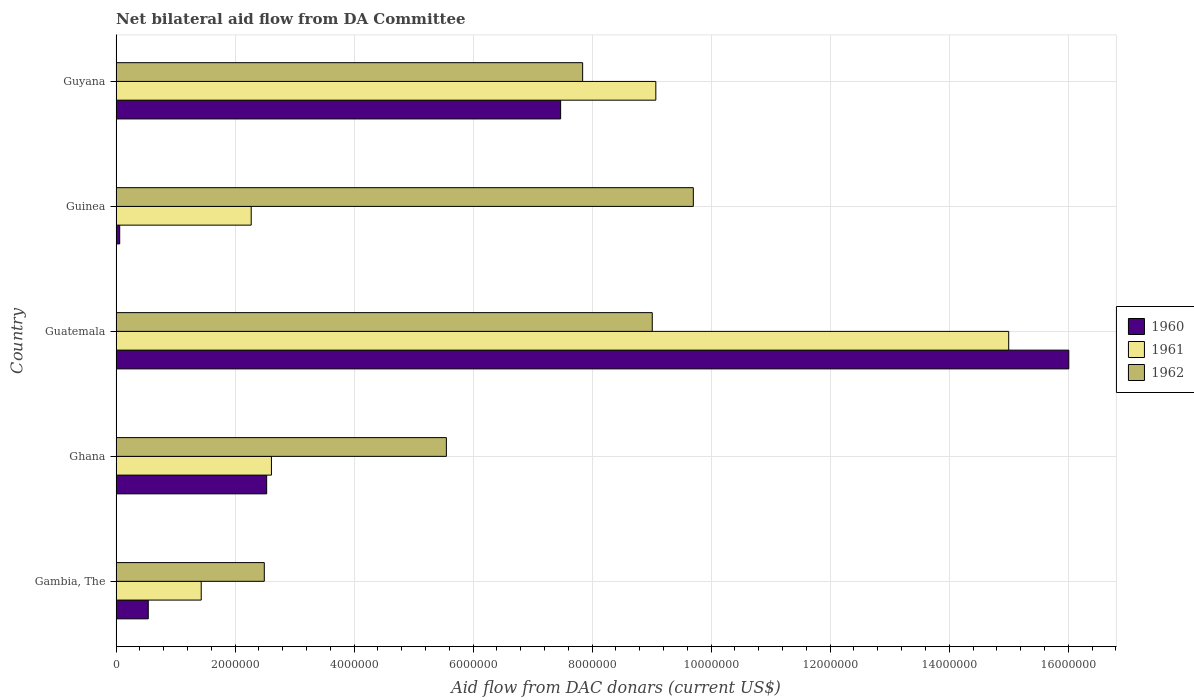How many groups of bars are there?
Give a very brief answer. 5. How many bars are there on the 4th tick from the top?
Keep it short and to the point. 3. How many bars are there on the 5th tick from the bottom?
Keep it short and to the point. 3. What is the label of the 4th group of bars from the top?
Your answer should be compact. Ghana. What is the aid flow in in 1962 in Guinea?
Make the answer very short. 9.70e+06. Across all countries, what is the maximum aid flow in in 1962?
Keep it short and to the point. 9.70e+06. Across all countries, what is the minimum aid flow in in 1962?
Offer a terse response. 2.49e+06. In which country was the aid flow in in 1961 maximum?
Your answer should be very brief. Guatemala. In which country was the aid flow in in 1961 minimum?
Your response must be concise. Gambia, The. What is the total aid flow in in 1962 in the graph?
Ensure brevity in your answer.  3.46e+07. What is the difference between the aid flow in in 1961 in Ghana and that in Guinea?
Offer a very short reply. 3.40e+05. What is the difference between the aid flow in in 1962 in Gambia, The and the aid flow in in 1961 in Guatemala?
Your answer should be compact. -1.25e+07. What is the average aid flow in in 1961 per country?
Offer a terse response. 6.08e+06. What is the difference between the aid flow in in 1961 and aid flow in in 1962 in Gambia, The?
Give a very brief answer. -1.06e+06. What is the ratio of the aid flow in in 1961 in Ghana to that in Guatemala?
Your answer should be very brief. 0.17. Is the aid flow in in 1962 in Gambia, The less than that in Guyana?
Offer a terse response. Yes. What is the difference between the highest and the second highest aid flow in in 1961?
Your answer should be very brief. 5.93e+06. What is the difference between the highest and the lowest aid flow in in 1960?
Provide a succinct answer. 1.60e+07. In how many countries, is the aid flow in in 1961 greater than the average aid flow in in 1961 taken over all countries?
Provide a short and direct response. 2. Is the sum of the aid flow in in 1960 in Ghana and Guyana greater than the maximum aid flow in in 1961 across all countries?
Provide a succinct answer. No. What does the 3rd bar from the top in Guinea represents?
Your answer should be very brief. 1960. How many bars are there?
Make the answer very short. 15. Are all the bars in the graph horizontal?
Offer a terse response. Yes. Are the values on the major ticks of X-axis written in scientific E-notation?
Offer a terse response. No. Does the graph contain any zero values?
Your response must be concise. No. Does the graph contain grids?
Ensure brevity in your answer.  Yes. Where does the legend appear in the graph?
Ensure brevity in your answer.  Center right. How many legend labels are there?
Offer a very short reply. 3. What is the title of the graph?
Offer a terse response. Net bilateral aid flow from DA Committee. What is the label or title of the X-axis?
Your answer should be very brief. Aid flow from DAC donars (current US$). What is the label or title of the Y-axis?
Ensure brevity in your answer.  Country. What is the Aid flow from DAC donars (current US$) in 1960 in Gambia, The?
Provide a short and direct response. 5.40e+05. What is the Aid flow from DAC donars (current US$) of 1961 in Gambia, The?
Ensure brevity in your answer.  1.43e+06. What is the Aid flow from DAC donars (current US$) of 1962 in Gambia, The?
Offer a terse response. 2.49e+06. What is the Aid flow from DAC donars (current US$) in 1960 in Ghana?
Your answer should be compact. 2.53e+06. What is the Aid flow from DAC donars (current US$) of 1961 in Ghana?
Offer a terse response. 2.61e+06. What is the Aid flow from DAC donars (current US$) in 1962 in Ghana?
Give a very brief answer. 5.55e+06. What is the Aid flow from DAC donars (current US$) of 1960 in Guatemala?
Give a very brief answer. 1.60e+07. What is the Aid flow from DAC donars (current US$) in 1961 in Guatemala?
Ensure brevity in your answer.  1.50e+07. What is the Aid flow from DAC donars (current US$) of 1962 in Guatemala?
Give a very brief answer. 9.01e+06. What is the Aid flow from DAC donars (current US$) in 1960 in Guinea?
Offer a terse response. 6.00e+04. What is the Aid flow from DAC donars (current US$) of 1961 in Guinea?
Your response must be concise. 2.27e+06. What is the Aid flow from DAC donars (current US$) of 1962 in Guinea?
Ensure brevity in your answer.  9.70e+06. What is the Aid flow from DAC donars (current US$) in 1960 in Guyana?
Ensure brevity in your answer.  7.47e+06. What is the Aid flow from DAC donars (current US$) of 1961 in Guyana?
Provide a succinct answer. 9.07e+06. What is the Aid flow from DAC donars (current US$) in 1962 in Guyana?
Offer a terse response. 7.84e+06. Across all countries, what is the maximum Aid flow from DAC donars (current US$) in 1960?
Keep it short and to the point. 1.60e+07. Across all countries, what is the maximum Aid flow from DAC donars (current US$) in 1961?
Offer a very short reply. 1.50e+07. Across all countries, what is the maximum Aid flow from DAC donars (current US$) in 1962?
Your answer should be compact. 9.70e+06. Across all countries, what is the minimum Aid flow from DAC donars (current US$) in 1960?
Offer a very short reply. 6.00e+04. Across all countries, what is the minimum Aid flow from DAC donars (current US$) in 1961?
Offer a very short reply. 1.43e+06. Across all countries, what is the minimum Aid flow from DAC donars (current US$) of 1962?
Your answer should be very brief. 2.49e+06. What is the total Aid flow from DAC donars (current US$) in 1960 in the graph?
Offer a very short reply. 2.66e+07. What is the total Aid flow from DAC donars (current US$) of 1961 in the graph?
Your answer should be very brief. 3.04e+07. What is the total Aid flow from DAC donars (current US$) in 1962 in the graph?
Provide a short and direct response. 3.46e+07. What is the difference between the Aid flow from DAC donars (current US$) of 1960 in Gambia, The and that in Ghana?
Provide a short and direct response. -1.99e+06. What is the difference between the Aid flow from DAC donars (current US$) of 1961 in Gambia, The and that in Ghana?
Your answer should be very brief. -1.18e+06. What is the difference between the Aid flow from DAC donars (current US$) of 1962 in Gambia, The and that in Ghana?
Give a very brief answer. -3.06e+06. What is the difference between the Aid flow from DAC donars (current US$) in 1960 in Gambia, The and that in Guatemala?
Ensure brevity in your answer.  -1.55e+07. What is the difference between the Aid flow from DAC donars (current US$) of 1961 in Gambia, The and that in Guatemala?
Ensure brevity in your answer.  -1.36e+07. What is the difference between the Aid flow from DAC donars (current US$) in 1962 in Gambia, The and that in Guatemala?
Your answer should be compact. -6.52e+06. What is the difference between the Aid flow from DAC donars (current US$) of 1960 in Gambia, The and that in Guinea?
Offer a terse response. 4.80e+05. What is the difference between the Aid flow from DAC donars (current US$) in 1961 in Gambia, The and that in Guinea?
Give a very brief answer. -8.40e+05. What is the difference between the Aid flow from DAC donars (current US$) of 1962 in Gambia, The and that in Guinea?
Provide a succinct answer. -7.21e+06. What is the difference between the Aid flow from DAC donars (current US$) in 1960 in Gambia, The and that in Guyana?
Give a very brief answer. -6.93e+06. What is the difference between the Aid flow from DAC donars (current US$) in 1961 in Gambia, The and that in Guyana?
Your answer should be compact. -7.64e+06. What is the difference between the Aid flow from DAC donars (current US$) in 1962 in Gambia, The and that in Guyana?
Offer a very short reply. -5.35e+06. What is the difference between the Aid flow from DAC donars (current US$) in 1960 in Ghana and that in Guatemala?
Provide a succinct answer. -1.35e+07. What is the difference between the Aid flow from DAC donars (current US$) in 1961 in Ghana and that in Guatemala?
Offer a very short reply. -1.24e+07. What is the difference between the Aid flow from DAC donars (current US$) in 1962 in Ghana and that in Guatemala?
Give a very brief answer. -3.46e+06. What is the difference between the Aid flow from DAC donars (current US$) in 1960 in Ghana and that in Guinea?
Ensure brevity in your answer.  2.47e+06. What is the difference between the Aid flow from DAC donars (current US$) of 1962 in Ghana and that in Guinea?
Your answer should be very brief. -4.15e+06. What is the difference between the Aid flow from DAC donars (current US$) of 1960 in Ghana and that in Guyana?
Ensure brevity in your answer.  -4.94e+06. What is the difference between the Aid flow from DAC donars (current US$) in 1961 in Ghana and that in Guyana?
Keep it short and to the point. -6.46e+06. What is the difference between the Aid flow from DAC donars (current US$) in 1962 in Ghana and that in Guyana?
Your answer should be very brief. -2.29e+06. What is the difference between the Aid flow from DAC donars (current US$) in 1960 in Guatemala and that in Guinea?
Keep it short and to the point. 1.60e+07. What is the difference between the Aid flow from DAC donars (current US$) of 1961 in Guatemala and that in Guinea?
Ensure brevity in your answer.  1.27e+07. What is the difference between the Aid flow from DAC donars (current US$) of 1962 in Guatemala and that in Guinea?
Offer a terse response. -6.90e+05. What is the difference between the Aid flow from DAC donars (current US$) in 1960 in Guatemala and that in Guyana?
Your response must be concise. 8.54e+06. What is the difference between the Aid flow from DAC donars (current US$) of 1961 in Guatemala and that in Guyana?
Your answer should be very brief. 5.93e+06. What is the difference between the Aid flow from DAC donars (current US$) of 1962 in Guatemala and that in Guyana?
Provide a short and direct response. 1.17e+06. What is the difference between the Aid flow from DAC donars (current US$) in 1960 in Guinea and that in Guyana?
Your response must be concise. -7.41e+06. What is the difference between the Aid flow from DAC donars (current US$) of 1961 in Guinea and that in Guyana?
Provide a succinct answer. -6.80e+06. What is the difference between the Aid flow from DAC donars (current US$) of 1962 in Guinea and that in Guyana?
Your answer should be compact. 1.86e+06. What is the difference between the Aid flow from DAC donars (current US$) of 1960 in Gambia, The and the Aid flow from DAC donars (current US$) of 1961 in Ghana?
Provide a short and direct response. -2.07e+06. What is the difference between the Aid flow from DAC donars (current US$) of 1960 in Gambia, The and the Aid flow from DAC donars (current US$) of 1962 in Ghana?
Offer a terse response. -5.01e+06. What is the difference between the Aid flow from DAC donars (current US$) of 1961 in Gambia, The and the Aid flow from DAC donars (current US$) of 1962 in Ghana?
Make the answer very short. -4.12e+06. What is the difference between the Aid flow from DAC donars (current US$) in 1960 in Gambia, The and the Aid flow from DAC donars (current US$) in 1961 in Guatemala?
Make the answer very short. -1.45e+07. What is the difference between the Aid flow from DAC donars (current US$) in 1960 in Gambia, The and the Aid flow from DAC donars (current US$) in 1962 in Guatemala?
Ensure brevity in your answer.  -8.47e+06. What is the difference between the Aid flow from DAC donars (current US$) in 1961 in Gambia, The and the Aid flow from DAC donars (current US$) in 1962 in Guatemala?
Provide a succinct answer. -7.58e+06. What is the difference between the Aid flow from DAC donars (current US$) in 1960 in Gambia, The and the Aid flow from DAC donars (current US$) in 1961 in Guinea?
Give a very brief answer. -1.73e+06. What is the difference between the Aid flow from DAC donars (current US$) in 1960 in Gambia, The and the Aid flow from DAC donars (current US$) in 1962 in Guinea?
Your answer should be compact. -9.16e+06. What is the difference between the Aid flow from DAC donars (current US$) in 1961 in Gambia, The and the Aid flow from DAC donars (current US$) in 1962 in Guinea?
Make the answer very short. -8.27e+06. What is the difference between the Aid flow from DAC donars (current US$) in 1960 in Gambia, The and the Aid flow from DAC donars (current US$) in 1961 in Guyana?
Make the answer very short. -8.53e+06. What is the difference between the Aid flow from DAC donars (current US$) in 1960 in Gambia, The and the Aid flow from DAC donars (current US$) in 1962 in Guyana?
Provide a succinct answer. -7.30e+06. What is the difference between the Aid flow from DAC donars (current US$) of 1961 in Gambia, The and the Aid flow from DAC donars (current US$) of 1962 in Guyana?
Provide a succinct answer. -6.41e+06. What is the difference between the Aid flow from DAC donars (current US$) of 1960 in Ghana and the Aid flow from DAC donars (current US$) of 1961 in Guatemala?
Your response must be concise. -1.25e+07. What is the difference between the Aid flow from DAC donars (current US$) of 1960 in Ghana and the Aid flow from DAC donars (current US$) of 1962 in Guatemala?
Your answer should be compact. -6.48e+06. What is the difference between the Aid flow from DAC donars (current US$) of 1961 in Ghana and the Aid flow from DAC donars (current US$) of 1962 in Guatemala?
Make the answer very short. -6.40e+06. What is the difference between the Aid flow from DAC donars (current US$) in 1960 in Ghana and the Aid flow from DAC donars (current US$) in 1961 in Guinea?
Your answer should be very brief. 2.60e+05. What is the difference between the Aid flow from DAC donars (current US$) in 1960 in Ghana and the Aid flow from DAC donars (current US$) in 1962 in Guinea?
Offer a terse response. -7.17e+06. What is the difference between the Aid flow from DAC donars (current US$) of 1961 in Ghana and the Aid flow from DAC donars (current US$) of 1962 in Guinea?
Ensure brevity in your answer.  -7.09e+06. What is the difference between the Aid flow from DAC donars (current US$) of 1960 in Ghana and the Aid flow from DAC donars (current US$) of 1961 in Guyana?
Offer a very short reply. -6.54e+06. What is the difference between the Aid flow from DAC donars (current US$) of 1960 in Ghana and the Aid flow from DAC donars (current US$) of 1962 in Guyana?
Offer a terse response. -5.31e+06. What is the difference between the Aid flow from DAC donars (current US$) in 1961 in Ghana and the Aid flow from DAC donars (current US$) in 1962 in Guyana?
Give a very brief answer. -5.23e+06. What is the difference between the Aid flow from DAC donars (current US$) of 1960 in Guatemala and the Aid flow from DAC donars (current US$) of 1961 in Guinea?
Ensure brevity in your answer.  1.37e+07. What is the difference between the Aid flow from DAC donars (current US$) of 1960 in Guatemala and the Aid flow from DAC donars (current US$) of 1962 in Guinea?
Ensure brevity in your answer.  6.31e+06. What is the difference between the Aid flow from DAC donars (current US$) of 1961 in Guatemala and the Aid flow from DAC donars (current US$) of 1962 in Guinea?
Ensure brevity in your answer.  5.30e+06. What is the difference between the Aid flow from DAC donars (current US$) in 1960 in Guatemala and the Aid flow from DAC donars (current US$) in 1961 in Guyana?
Your answer should be very brief. 6.94e+06. What is the difference between the Aid flow from DAC donars (current US$) in 1960 in Guatemala and the Aid flow from DAC donars (current US$) in 1962 in Guyana?
Your answer should be very brief. 8.17e+06. What is the difference between the Aid flow from DAC donars (current US$) of 1961 in Guatemala and the Aid flow from DAC donars (current US$) of 1962 in Guyana?
Provide a short and direct response. 7.16e+06. What is the difference between the Aid flow from DAC donars (current US$) of 1960 in Guinea and the Aid flow from DAC donars (current US$) of 1961 in Guyana?
Keep it short and to the point. -9.01e+06. What is the difference between the Aid flow from DAC donars (current US$) of 1960 in Guinea and the Aid flow from DAC donars (current US$) of 1962 in Guyana?
Give a very brief answer. -7.78e+06. What is the difference between the Aid flow from DAC donars (current US$) of 1961 in Guinea and the Aid flow from DAC donars (current US$) of 1962 in Guyana?
Your answer should be very brief. -5.57e+06. What is the average Aid flow from DAC donars (current US$) in 1960 per country?
Give a very brief answer. 5.32e+06. What is the average Aid flow from DAC donars (current US$) of 1961 per country?
Your response must be concise. 6.08e+06. What is the average Aid flow from DAC donars (current US$) in 1962 per country?
Your answer should be very brief. 6.92e+06. What is the difference between the Aid flow from DAC donars (current US$) in 1960 and Aid flow from DAC donars (current US$) in 1961 in Gambia, The?
Keep it short and to the point. -8.90e+05. What is the difference between the Aid flow from DAC donars (current US$) of 1960 and Aid flow from DAC donars (current US$) of 1962 in Gambia, The?
Keep it short and to the point. -1.95e+06. What is the difference between the Aid flow from DAC donars (current US$) of 1961 and Aid flow from DAC donars (current US$) of 1962 in Gambia, The?
Make the answer very short. -1.06e+06. What is the difference between the Aid flow from DAC donars (current US$) in 1960 and Aid flow from DAC donars (current US$) in 1962 in Ghana?
Your answer should be compact. -3.02e+06. What is the difference between the Aid flow from DAC donars (current US$) in 1961 and Aid flow from DAC donars (current US$) in 1962 in Ghana?
Your answer should be compact. -2.94e+06. What is the difference between the Aid flow from DAC donars (current US$) in 1960 and Aid flow from DAC donars (current US$) in 1961 in Guatemala?
Ensure brevity in your answer.  1.01e+06. What is the difference between the Aid flow from DAC donars (current US$) of 1961 and Aid flow from DAC donars (current US$) of 1962 in Guatemala?
Keep it short and to the point. 5.99e+06. What is the difference between the Aid flow from DAC donars (current US$) in 1960 and Aid flow from DAC donars (current US$) in 1961 in Guinea?
Ensure brevity in your answer.  -2.21e+06. What is the difference between the Aid flow from DAC donars (current US$) in 1960 and Aid flow from DAC donars (current US$) in 1962 in Guinea?
Keep it short and to the point. -9.64e+06. What is the difference between the Aid flow from DAC donars (current US$) in 1961 and Aid flow from DAC donars (current US$) in 1962 in Guinea?
Offer a terse response. -7.43e+06. What is the difference between the Aid flow from DAC donars (current US$) of 1960 and Aid flow from DAC donars (current US$) of 1961 in Guyana?
Your answer should be compact. -1.60e+06. What is the difference between the Aid flow from DAC donars (current US$) in 1960 and Aid flow from DAC donars (current US$) in 1962 in Guyana?
Provide a short and direct response. -3.70e+05. What is the difference between the Aid flow from DAC donars (current US$) of 1961 and Aid flow from DAC donars (current US$) of 1962 in Guyana?
Offer a terse response. 1.23e+06. What is the ratio of the Aid flow from DAC donars (current US$) of 1960 in Gambia, The to that in Ghana?
Offer a terse response. 0.21. What is the ratio of the Aid flow from DAC donars (current US$) of 1961 in Gambia, The to that in Ghana?
Your answer should be very brief. 0.55. What is the ratio of the Aid flow from DAC donars (current US$) of 1962 in Gambia, The to that in Ghana?
Ensure brevity in your answer.  0.45. What is the ratio of the Aid flow from DAC donars (current US$) of 1960 in Gambia, The to that in Guatemala?
Give a very brief answer. 0.03. What is the ratio of the Aid flow from DAC donars (current US$) in 1961 in Gambia, The to that in Guatemala?
Your answer should be very brief. 0.1. What is the ratio of the Aid flow from DAC donars (current US$) in 1962 in Gambia, The to that in Guatemala?
Ensure brevity in your answer.  0.28. What is the ratio of the Aid flow from DAC donars (current US$) of 1961 in Gambia, The to that in Guinea?
Make the answer very short. 0.63. What is the ratio of the Aid flow from DAC donars (current US$) of 1962 in Gambia, The to that in Guinea?
Offer a terse response. 0.26. What is the ratio of the Aid flow from DAC donars (current US$) of 1960 in Gambia, The to that in Guyana?
Your answer should be very brief. 0.07. What is the ratio of the Aid flow from DAC donars (current US$) in 1961 in Gambia, The to that in Guyana?
Give a very brief answer. 0.16. What is the ratio of the Aid flow from DAC donars (current US$) in 1962 in Gambia, The to that in Guyana?
Offer a terse response. 0.32. What is the ratio of the Aid flow from DAC donars (current US$) of 1960 in Ghana to that in Guatemala?
Offer a terse response. 0.16. What is the ratio of the Aid flow from DAC donars (current US$) in 1961 in Ghana to that in Guatemala?
Offer a terse response. 0.17. What is the ratio of the Aid flow from DAC donars (current US$) in 1962 in Ghana to that in Guatemala?
Keep it short and to the point. 0.62. What is the ratio of the Aid flow from DAC donars (current US$) in 1960 in Ghana to that in Guinea?
Your response must be concise. 42.17. What is the ratio of the Aid flow from DAC donars (current US$) of 1961 in Ghana to that in Guinea?
Your answer should be compact. 1.15. What is the ratio of the Aid flow from DAC donars (current US$) in 1962 in Ghana to that in Guinea?
Provide a succinct answer. 0.57. What is the ratio of the Aid flow from DAC donars (current US$) of 1960 in Ghana to that in Guyana?
Provide a short and direct response. 0.34. What is the ratio of the Aid flow from DAC donars (current US$) in 1961 in Ghana to that in Guyana?
Give a very brief answer. 0.29. What is the ratio of the Aid flow from DAC donars (current US$) in 1962 in Ghana to that in Guyana?
Your response must be concise. 0.71. What is the ratio of the Aid flow from DAC donars (current US$) of 1960 in Guatemala to that in Guinea?
Keep it short and to the point. 266.83. What is the ratio of the Aid flow from DAC donars (current US$) in 1961 in Guatemala to that in Guinea?
Your answer should be very brief. 6.61. What is the ratio of the Aid flow from DAC donars (current US$) of 1962 in Guatemala to that in Guinea?
Make the answer very short. 0.93. What is the ratio of the Aid flow from DAC donars (current US$) of 1960 in Guatemala to that in Guyana?
Your answer should be compact. 2.14. What is the ratio of the Aid flow from DAC donars (current US$) in 1961 in Guatemala to that in Guyana?
Offer a terse response. 1.65. What is the ratio of the Aid flow from DAC donars (current US$) in 1962 in Guatemala to that in Guyana?
Your answer should be very brief. 1.15. What is the ratio of the Aid flow from DAC donars (current US$) of 1960 in Guinea to that in Guyana?
Provide a succinct answer. 0.01. What is the ratio of the Aid flow from DAC donars (current US$) of 1961 in Guinea to that in Guyana?
Offer a very short reply. 0.25. What is the ratio of the Aid flow from DAC donars (current US$) of 1962 in Guinea to that in Guyana?
Make the answer very short. 1.24. What is the difference between the highest and the second highest Aid flow from DAC donars (current US$) in 1960?
Your response must be concise. 8.54e+06. What is the difference between the highest and the second highest Aid flow from DAC donars (current US$) of 1961?
Provide a succinct answer. 5.93e+06. What is the difference between the highest and the second highest Aid flow from DAC donars (current US$) in 1962?
Offer a terse response. 6.90e+05. What is the difference between the highest and the lowest Aid flow from DAC donars (current US$) of 1960?
Your answer should be compact. 1.60e+07. What is the difference between the highest and the lowest Aid flow from DAC donars (current US$) of 1961?
Offer a terse response. 1.36e+07. What is the difference between the highest and the lowest Aid flow from DAC donars (current US$) of 1962?
Your answer should be very brief. 7.21e+06. 